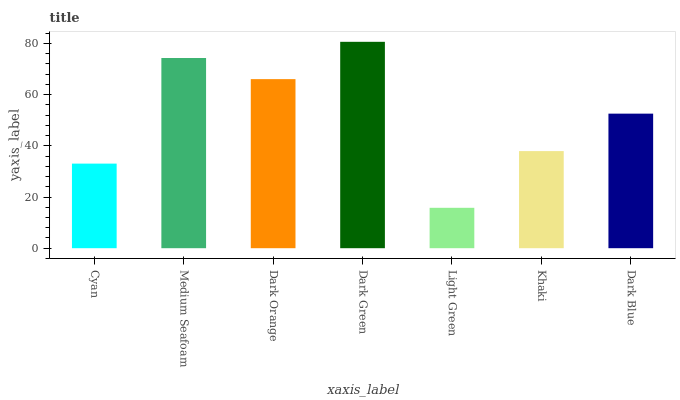Is Light Green the minimum?
Answer yes or no. Yes. Is Dark Green the maximum?
Answer yes or no. Yes. Is Medium Seafoam the minimum?
Answer yes or no. No. Is Medium Seafoam the maximum?
Answer yes or no. No. Is Medium Seafoam greater than Cyan?
Answer yes or no. Yes. Is Cyan less than Medium Seafoam?
Answer yes or no. Yes. Is Cyan greater than Medium Seafoam?
Answer yes or no. No. Is Medium Seafoam less than Cyan?
Answer yes or no. No. Is Dark Blue the high median?
Answer yes or no. Yes. Is Dark Blue the low median?
Answer yes or no. Yes. Is Dark Green the high median?
Answer yes or no. No. Is Light Green the low median?
Answer yes or no. No. 